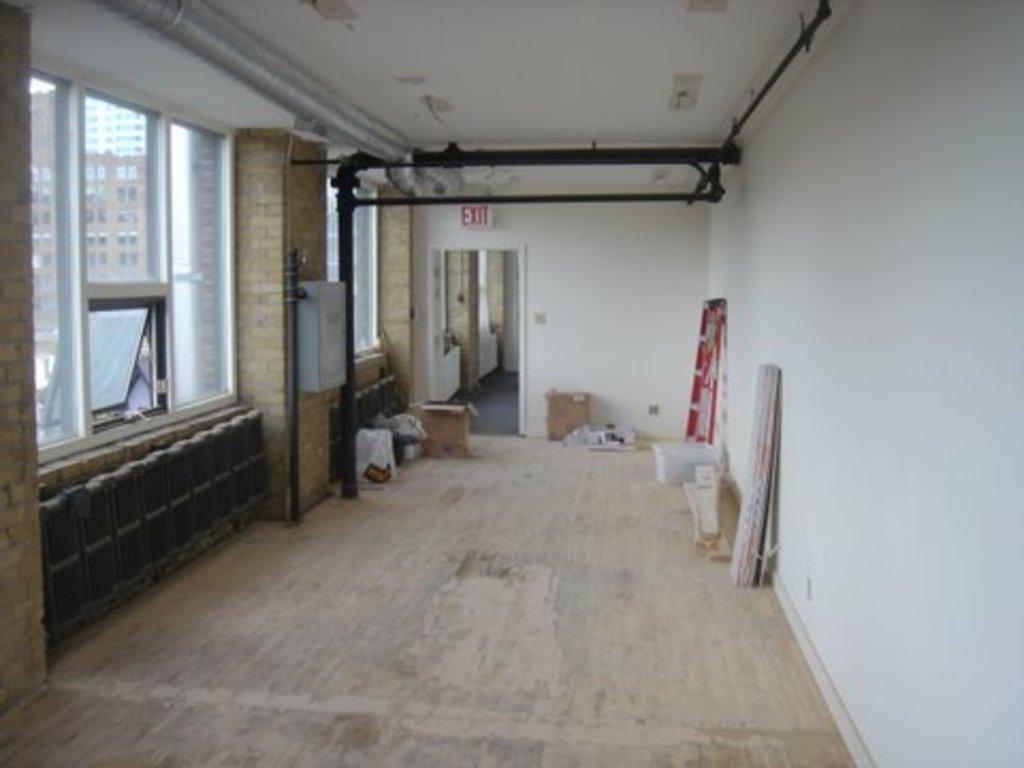Can you describe this image briefly? This image is taken from inside. On the right side of the image there is a wall. On the left side of the image there is a glass window attached to the wall. At the top there is a ceiling. At the bottom there is a floor. On the floor there are some objects. 